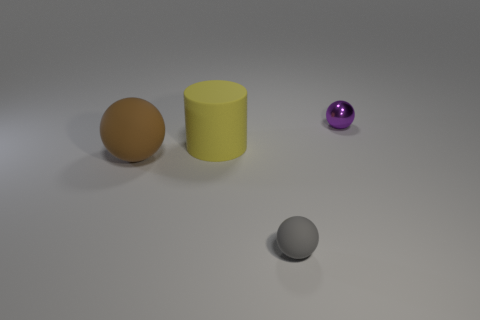There is a tiny purple ball that is right of the rubber sphere that is left of the gray matte object; what is it made of?
Your answer should be very brief. Metal. There is a small thing that is in front of the tiny ball that is behind the object on the left side of the cylinder; what shape is it?
Keep it short and to the point. Sphere. There is a big brown thing that is the same shape as the purple object; what is its material?
Give a very brief answer. Rubber. What number of big yellow objects are there?
Your response must be concise. 1. There is a tiny thing to the left of the purple sphere; what shape is it?
Your answer should be very brief. Sphere. What is the color of the big thing behind the matte ball behind the matte thing that is on the right side of the big yellow matte thing?
Offer a terse response. Yellow. There is a brown thing that is made of the same material as the yellow cylinder; what shape is it?
Your response must be concise. Sphere. Are there fewer blocks than purple objects?
Keep it short and to the point. Yes. Is the brown thing made of the same material as the big yellow object?
Make the answer very short. Yes. How many other things are there of the same color as the small metal object?
Provide a succinct answer. 0. 